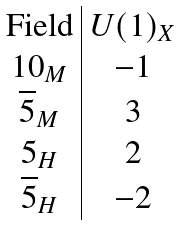<formula> <loc_0><loc_0><loc_500><loc_500>\begin{array} { c | c } \text {Field} & U ( 1 ) _ { X } \\ 1 0 _ { M } & - 1 \\ \overline { 5 } _ { M } & 3 \\ 5 _ { H } & 2 \\ \overline { 5 } _ { H } & - 2 \end{array}</formula> 